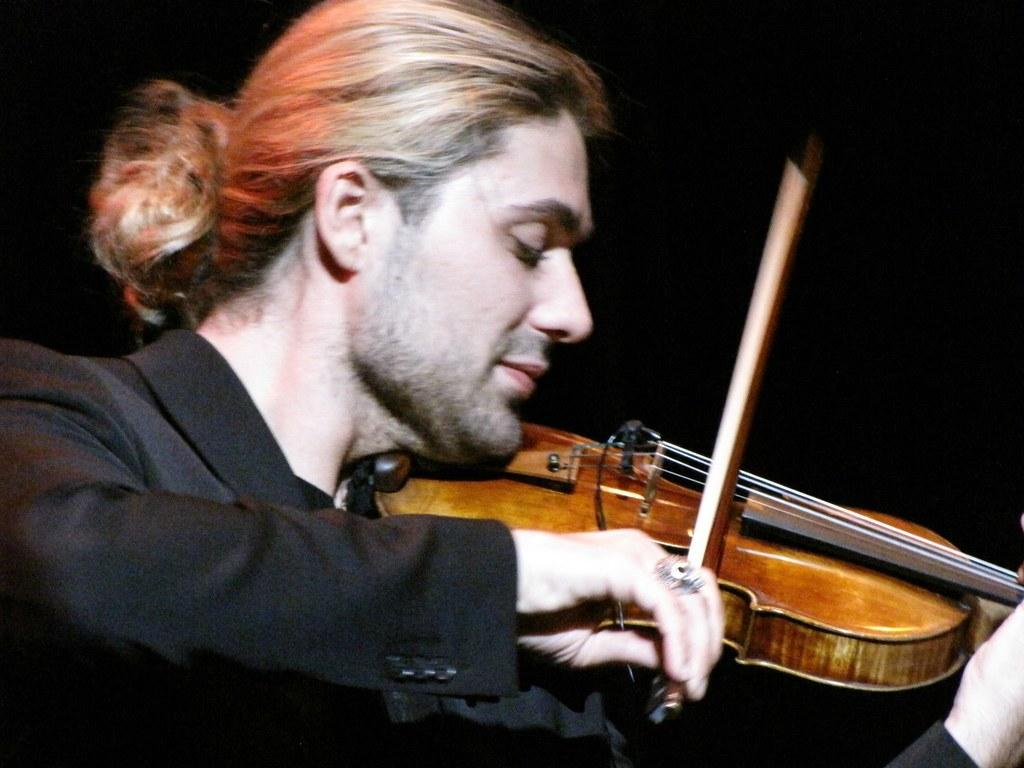What is the man in the image doing? The man is playing the guitar. What instrument is the man holding in the image? The man is holding a guitar. What is the man wearing on his upper body in the image? The man is wearing a black blazer. What type of accessory is the man wearing on his finger in the image? The man is wearing a finger ring. What type of vessel is the man using to stretch in the image? There is no vessel present in the image, and the man is not stretching. 